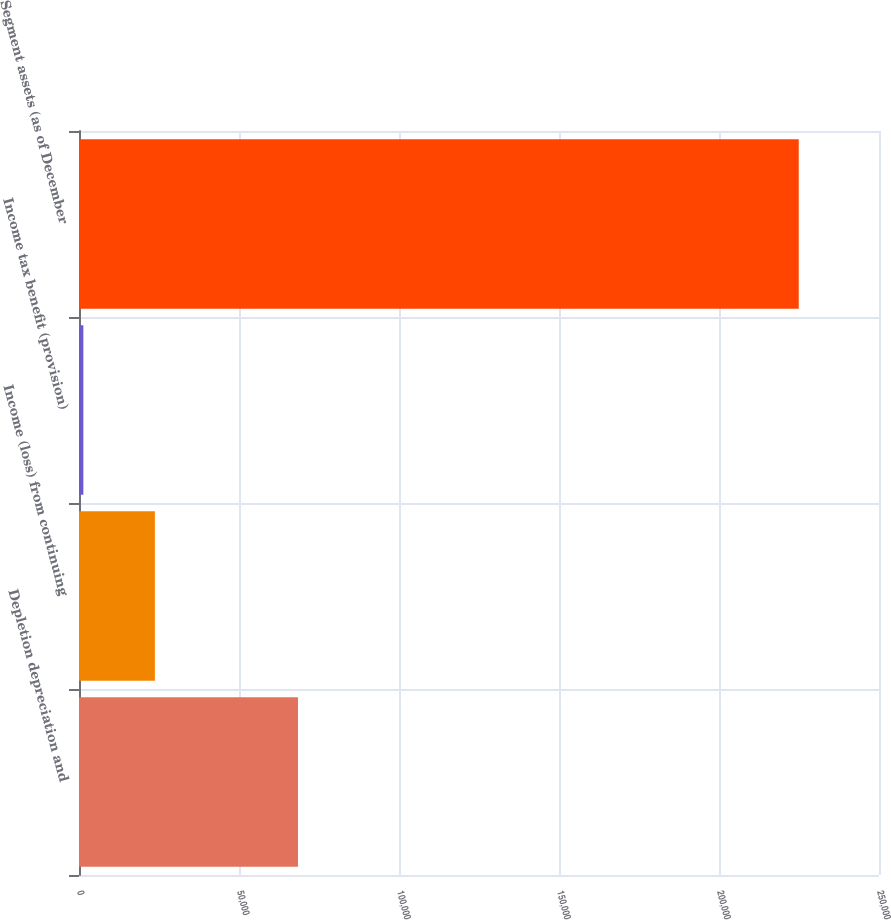<chart> <loc_0><loc_0><loc_500><loc_500><bar_chart><fcel>Depletion depreciation and<fcel>Income (loss) from continuing<fcel>Income tax benefit (provision)<fcel>Segment assets (as of December<nl><fcel>68430.4<fcel>23718.8<fcel>1363<fcel>224921<nl></chart> 